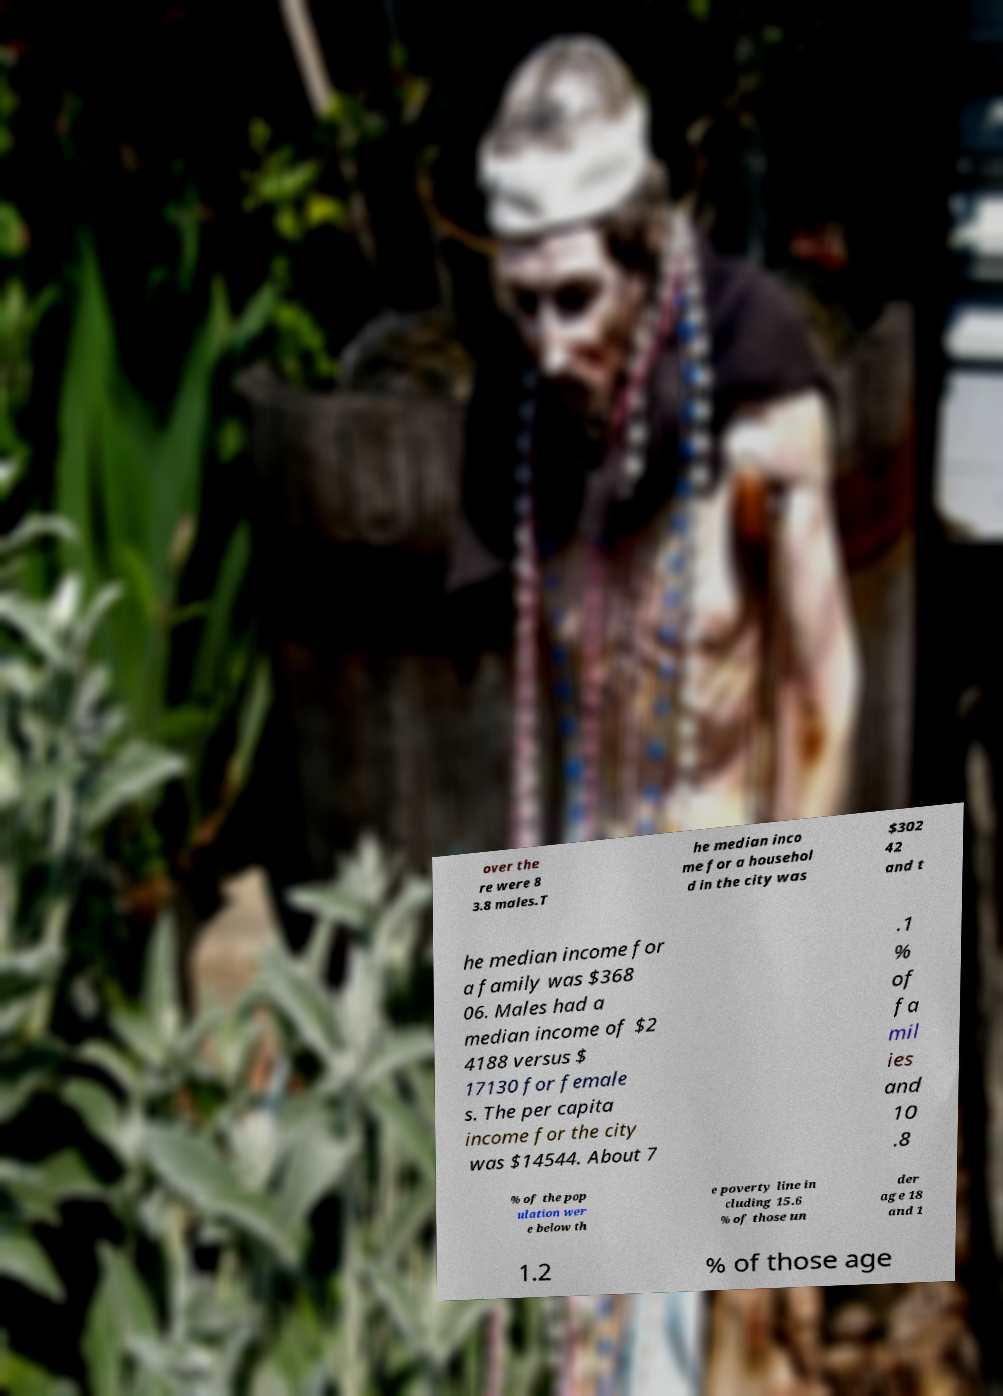Could you assist in decoding the text presented in this image and type it out clearly? over the re were 8 3.8 males.T he median inco me for a househol d in the city was $302 42 and t he median income for a family was $368 06. Males had a median income of $2 4188 versus $ 17130 for female s. The per capita income for the city was $14544. About 7 .1 % of fa mil ies and 10 .8 % of the pop ulation wer e below th e poverty line in cluding 15.6 % of those un der age 18 and 1 1.2 % of those age 